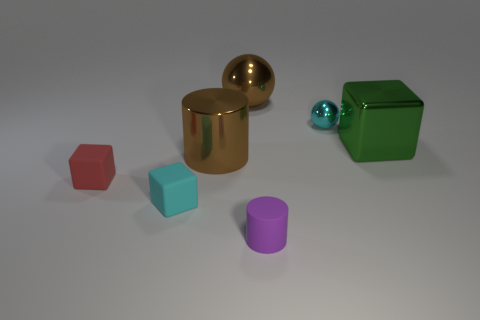What number of things are either brown shiny cylinders or brown things that are behind the small metallic ball?
Provide a succinct answer. 2. Does the tiny ball have the same material as the purple cylinder?
Make the answer very short. No. How many other things are there of the same material as the brown ball?
Offer a very short reply. 3. Are there more big cyan metal cubes than metallic blocks?
Make the answer very short. No. Does the cyan thing that is behind the brown metal cylinder have the same shape as the red rubber object?
Offer a very short reply. No. Are there fewer spheres than cyan balls?
Provide a short and direct response. No. There is a cylinder that is the same size as the cyan matte object; what is its material?
Make the answer very short. Rubber. Does the tiny metallic sphere have the same color as the block that is behind the large brown shiny cylinder?
Offer a very short reply. No. Is the number of tiny cyan spheres that are to the right of the small cyan metallic sphere less than the number of small purple objects?
Provide a succinct answer. Yes. What number of large yellow matte cubes are there?
Give a very brief answer. 0. 